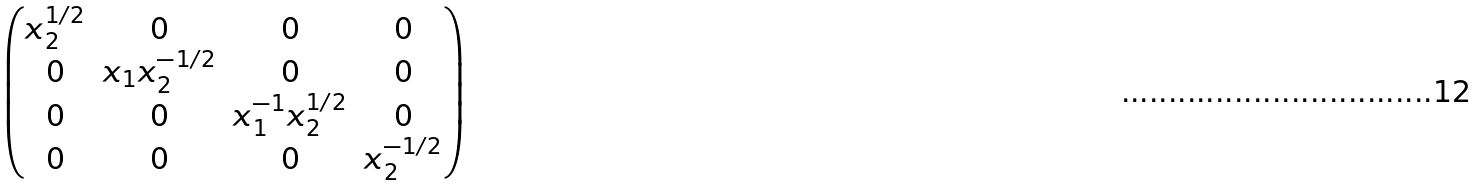Convert formula to latex. <formula><loc_0><loc_0><loc_500><loc_500>\begin{pmatrix} x _ { 2 } ^ { 1 / 2 } & 0 & 0 & 0 \\ 0 & x _ { 1 } x _ { 2 } ^ { - 1 / 2 } & 0 & 0 \\ 0 & 0 & x _ { 1 } ^ { - 1 } x _ { 2 } ^ { 1 / 2 } & 0 \\ 0 & 0 & 0 & x _ { 2 } ^ { - 1 / 2 } \\ \end{pmatrix}</formula> 